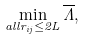<formula> <loc_0><loc_0><loc_500><loc_500>\min _ { a l l r _ { i j } \leq 2 L } { \overline { \Lambda } } ,</formula> 